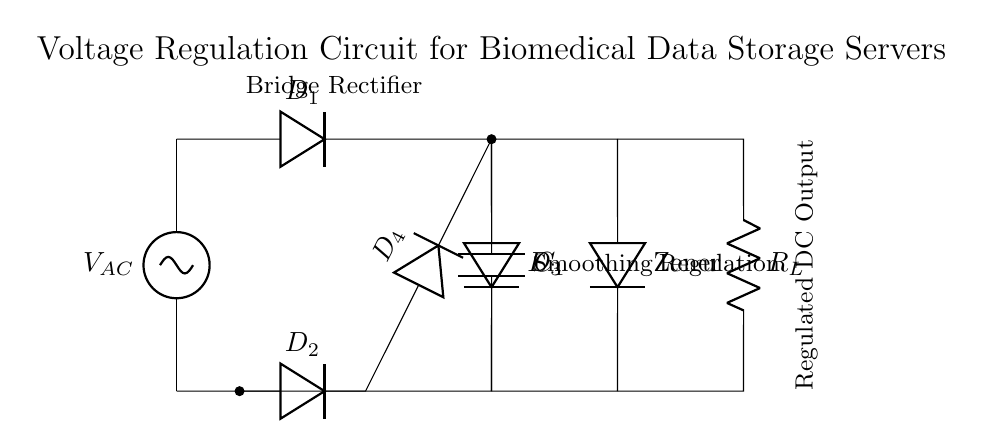What type of rectifier is shown in the circuit? The circuit diagram depicts a bridge rectifier, which is composed of four diodes arranged in a bridge configuration to efficiently convert AC to DC.
Answer: Bridge rectifier What is the purpose of the smoothing capacitor in the circuit? The smoothing capacitor's role is to reduce the ripple voltage in the output after rectification, providing a more stable DC voltage suitable for the biomedical data storage servers.
Answer: Reduce ripple voltage How many diodes are used in the rectification process? The rectification process utilizes four diodes arranged in the bridge configuration, allowing for full-wave rectification of the AC input voltage.
Answer: Four diodes What component regulates the output voltage? The component that regulates the output voltage is the Zener diode, which ensures a constant output voltage across the load by diverting excess voltage.
Answer: Zener diode What is the value of the load resistor in the circuit? The load resistor value is denoted as R_L in the diagram; its specific resistance value is not provided but is typically chosen based on the application requirements for the biomedical data storage.
Answer: R_L (value not specified) Why are there two distinct sections marked as smoothing and regulation? The circuit is deliberately divided into smoothing and regulation sections to indicate the specific functions: the smoothing section deals with filtering the output from the rectifier to reduce ripple, while the regulation section ensures that the output voltage remains stable regardless of changes in load or input voltage.
Answer: Different functions: smoothing and regulation What shape is the waveform after the rectification process? The waveform shape after rectification in a bridge configuration typically resembles a pulsating DC waveform, characterized by positive half cycles corresponding to the input AC waveform, with a reduced ripple due to the smoothing capacitor.
Answer: Pulsating DC waveform 